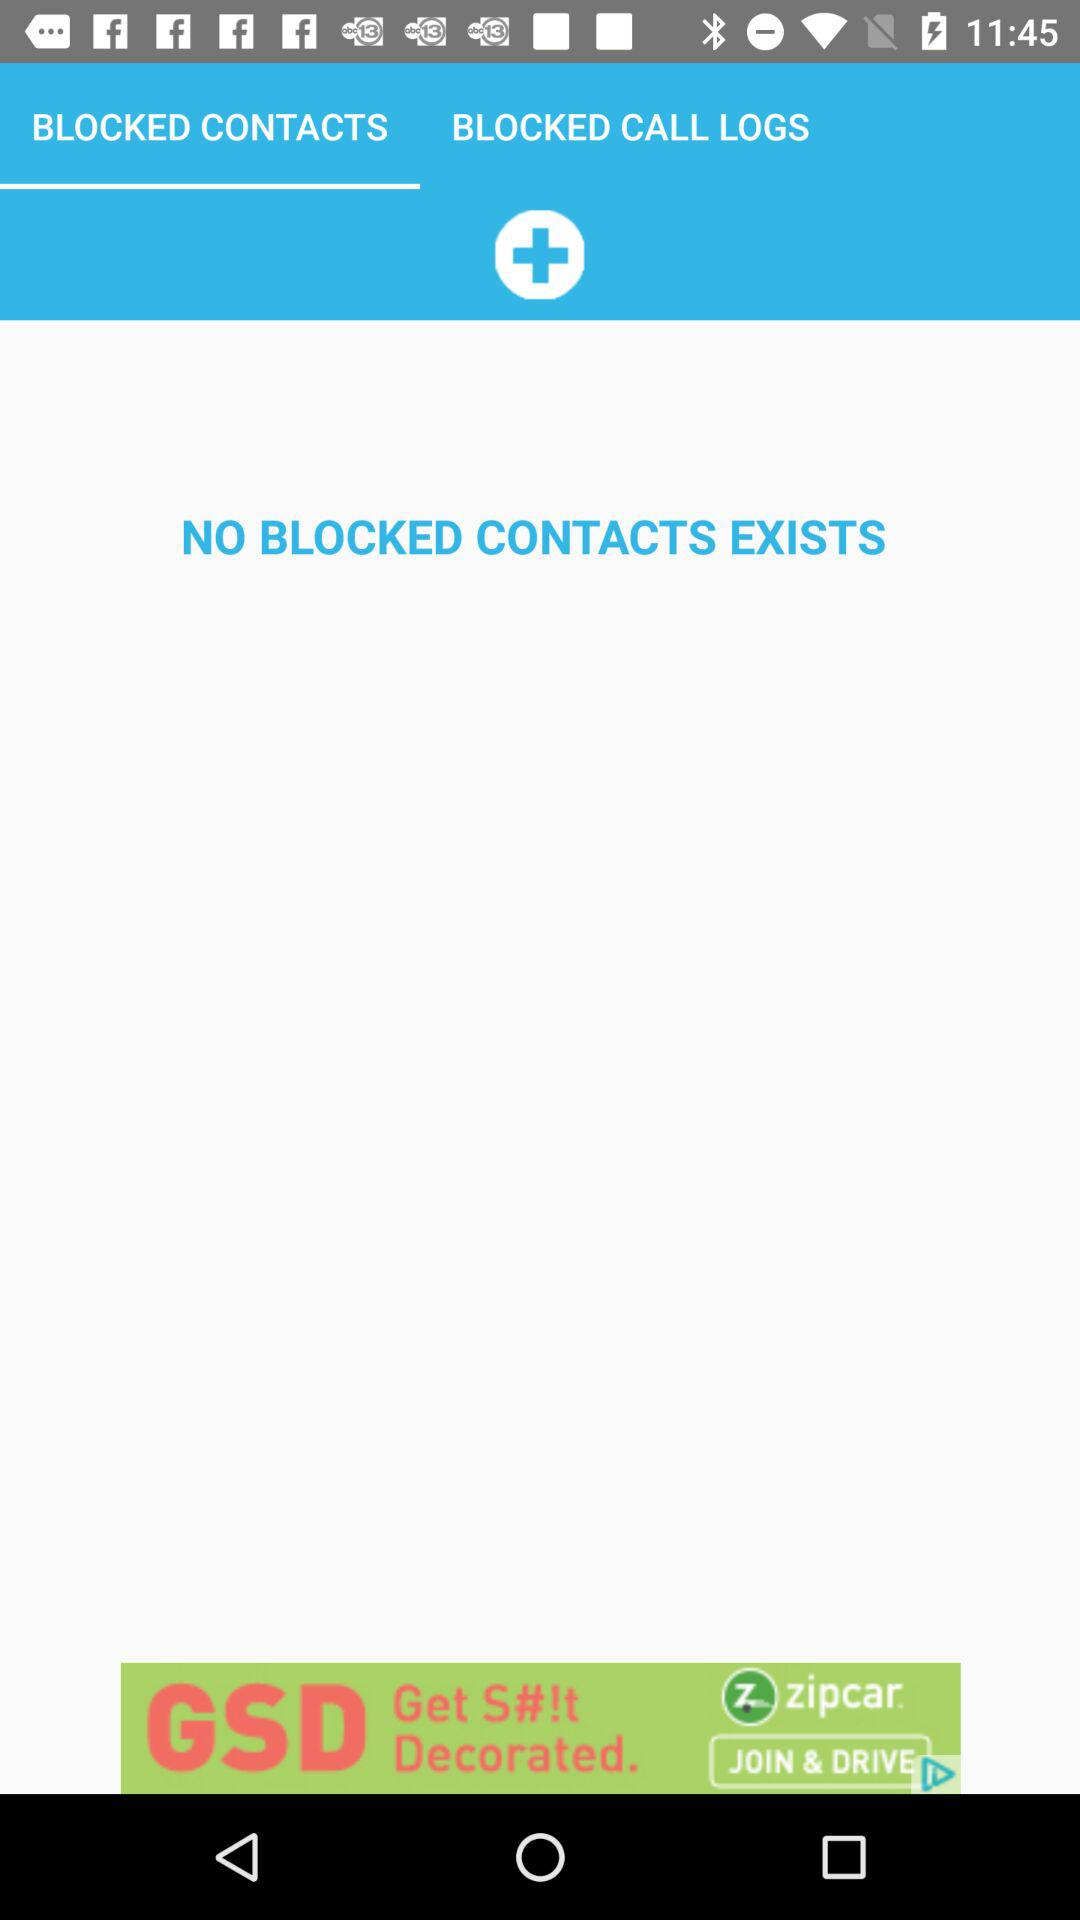What is the selected tab right now? The selected tab right now is "BLOCKED CONTACTS". 